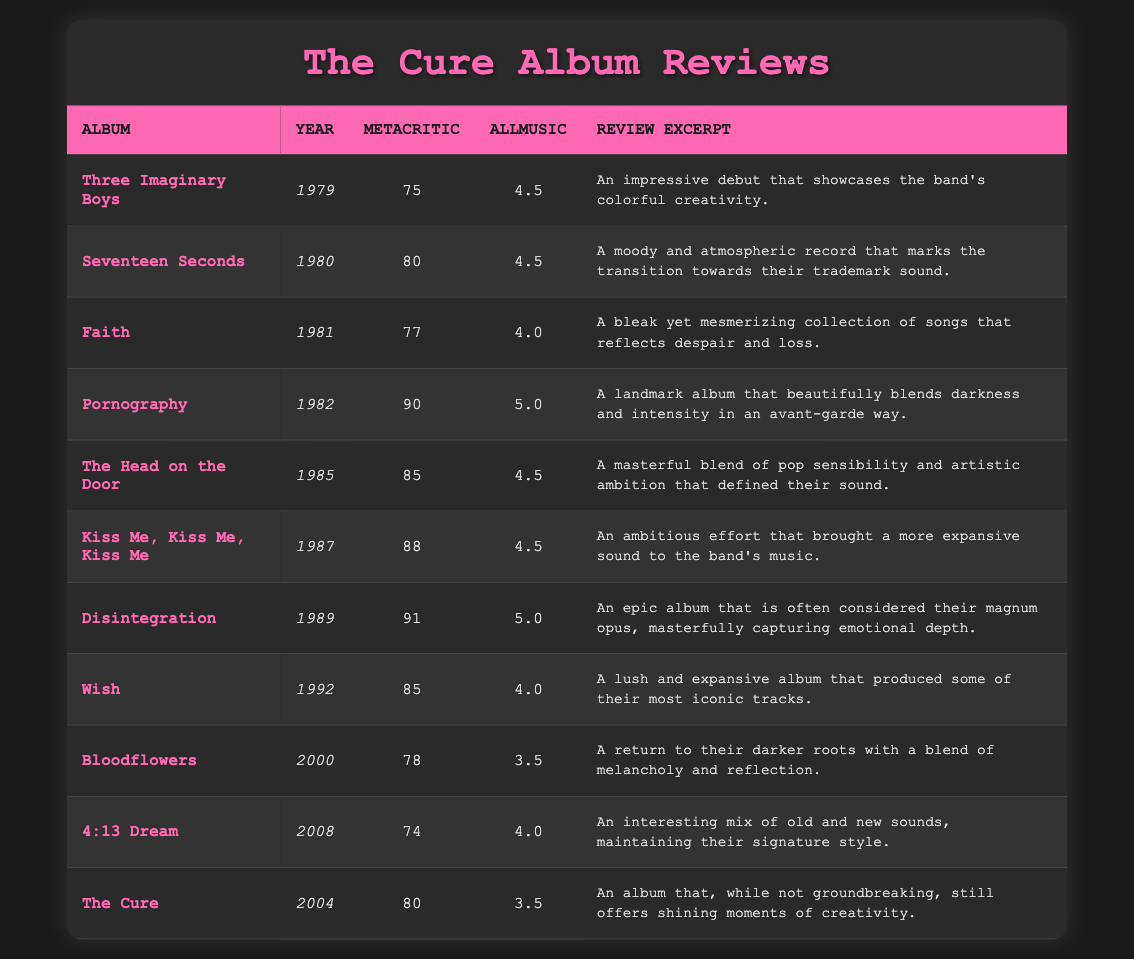What is the highest Metacritic score among The Cure's albums? The highest Metacritic score in the table is found by scanning through the Metacritic scores listed for each album. The album "Disintegration" has a score of 91, which is higher than all other albums listed.
Answer: 91 Which album received an AllMusic rating of 5.0? To answer this, we look for the entries in the AllMusic column and check which ones have a rating of 5.0. "Pornography" and "Disintegration" both received this rating.
Answer: Pornography and Disintegration What year was the album "Wish" released? The year of release for the album "Wish" can be found in the "Year" column next to its name. It shows that "Wish" was released in 1992.
Answer: 1992 What is the average Metacritic score of the albums released in the 1980s? To calculate the average, sum the Metacritic scores of the albums released during the 1980s: "Seventeen Seconds" (80) + "The Head on the Door" (85) + "Kiss Me, Kiss Me, Kiss Me" (88) + "Disintegration" (91) = 344. There are 4 albums, so the average is 344 / 4 = 86.
Answer: 86 Was "Bloodflowers" rated higher than "The Cure" on AllMusic? We compare the AllMusic ratings between "Bloodflowers" (3.5) and "The Cure" (3.5). Since both albums received the same rating, "Bloodflowers" was not rated higher.
Answer: No What is the Metacritic score difference between "Pornography" and "Bloodflowers"? The score for "Pornography" is 90 and for "Bloodflowers" it is 78. The difference is calculated by subtracting 78 from 90, which gives 90 - 78 = 12.
Answer: 12 How many albums have a Metacritic score above 80? Count the albums in the table with Metacritic scores greater than 80. These albums are "Seventeen Seconds" (80), "Pornography" (90), "The Head on the Door" (85), "Kiss Me, Kiss Me, Kiss Me" (88), "Disintegration" (91), and "Wish" (85), resulting in a total of 5 albums.
Answer: 5 Which album has the lowest AllMusic rating, and what is that rating? Scan the AllMusic ratings in the table for the lowest rating. "Bloodflowers" has a rating of 3.5, and "4:13 Dream" is also rated 4.0, making "Bloodflowers" the lowest.
Answer: Bloodflowers, 3.5 What album represents the transition toward The Cure's trademark sound, and what is its Metacritic score? The album "Seventeen Seconds" is noted as marking this transition, and referring to the table, it has a Metacritic score of 80.
Answer: Seventeen Seconds, 80 